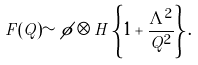Convert formula to latex. <formula><loc_0><loc_0><loc_500><loc_500>F ( Q ) \sim \phi \otimes H \left \{ 1 + \frac { \Lambda ^ { 2 } } { Q ^ { 2 } } \right \} .</formula> 